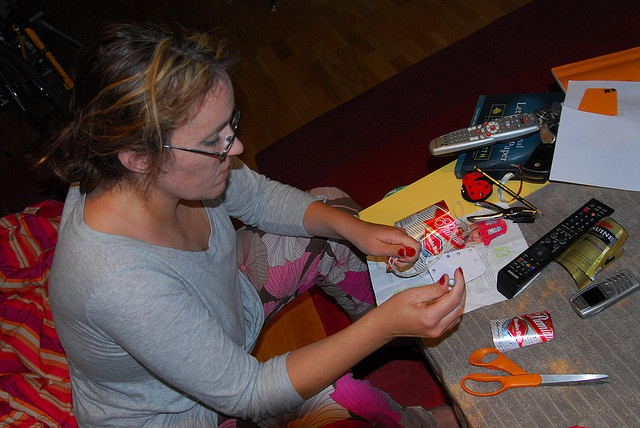Describe the objects in this image and their specific colors. I can see people in black, gray, and brown tones, couch in black, gray, and maroon tones, book in black, darkblue, gray, and blue tones, remote in black, gray, and maroon tones, and scissors in black, red, gray, and brown tones in this image. 